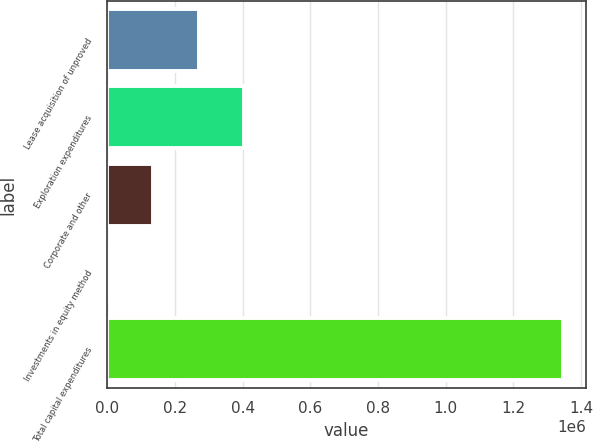<chart> <loc_0><loc_0><loc_500><loc_500><bar_chart><fcel>Lease acquisition of unproved<fcel>Exploration expenditures<fcel>Corporate and other<fcel>Investments in equity method<fcel>Total capital expenditures<nl><fcel>269887<fcel>404541<fcel>135234<fcel>580<fcel>1.34712e+06<nl></chart> 